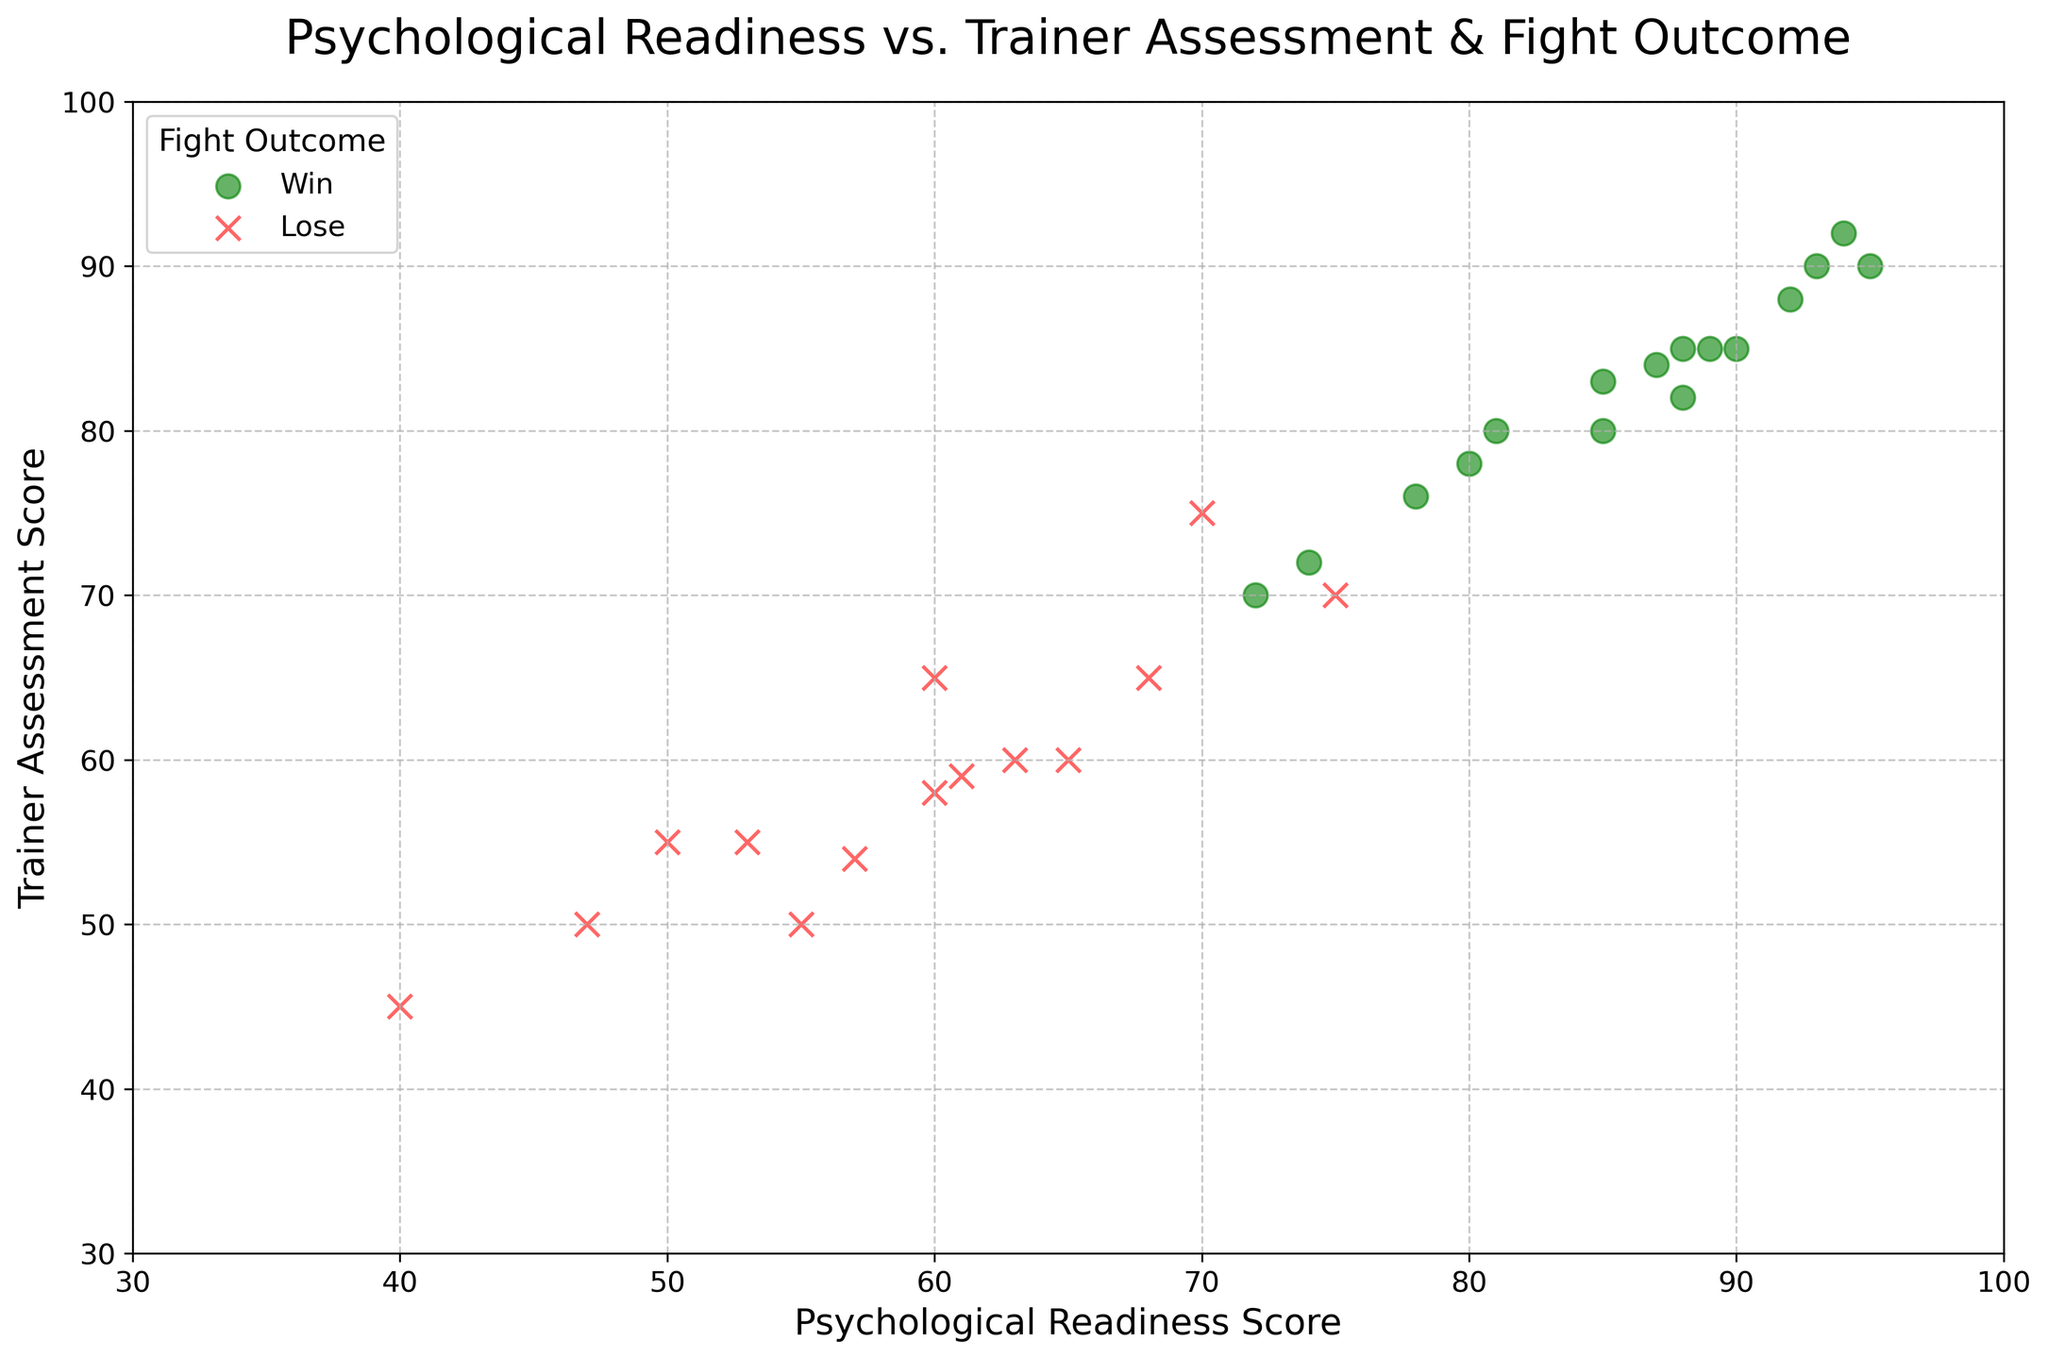What colors represent the winning and losing outcomes in the plot? The plot uses different colors to differentiate between winning and losing outcomes. By observing the legend, we can see that "Win" is represented by green, and "Lose" is represented by red.
Answer: Winning is green, Losing is red What is the common range of Psychological Readiness Scores for fighters who win? By observing the scatter plot, we see the green markers, which represent the winning fighters, are generally clustered between 80 and 95 on the Psychological Readiness Score axis.
Answer: 80 to 95 Which fighter has the highest Psychological Readiness Score? Did they win or lose their fight? The highest Psychological Readiness Score is 95, indicated by a green marker (win) in the scatter plot. The fighter with this score won their fight.
Answer: Fighter with 95 psychological readiness, Win Compare the Psychological Readiness Scores and Trainer Assessment Scores for winners and losers. Which group tends to have higher scores? By comparing the clusters of green (winners) and red (losers) markers, we observe that the green markers are generally in the higher range of both Psychological Readiness Scores and Trainer Assessment Scores, indicating that winners tend to have higher scores in both metrics.
Answer: Winners have higher scores What is the average Psychological Readiness Score of the losing fighters? The Psychological Readiness Scores of the losing fighters are 75, 60, 50, 70, 65, 55, 40, 47, 60, 53, 63, 57, and 61. Counting up these values and dividing by the number of values gives an average of (75 + 60 + 50 + 70 + 65 + 55 + 40 + 47 + 60 + 53 + 63 + 57 + 61) / 13 ≈ 58.54.
Answer: Approximately 58.54 Which Psychological Readiness Score has a corresponding Trainer Assessment Score of 60? Did that fighter win or lose? Referring to the scatter plot, we identify a red marker (lose) at the coordinates (65, 60) and another red marker at (63, 60). Both fighters with Psychological Readiness Scores of 65 and 63 have a Trainer Assessment Score of 60, and both lost their fights.
Answer: 65 and 63, both lost How many fighters scored below 60 on the Psychological Readiness Scale? How many of them won their fights? Observing the scatter plot, we count the markers below the Psychological Readiness Score of 60 and find three red markers (losers) at 50, 55, 40, 47, 53, and 57. None of these markers are green, hence none of these fighters won their fights.
Answer: 6 fighters, 0 wins Compare the largest Psychological Readiness Score difference between any two winning fighters. The range of Psychological Readiness Scores for winning fighters is from 72 to 95. The largest difference between any two winning fighters is 95 - 72 = 23.
Answer: 23 Is there a visible trend between Psychological Readiness Scores and Trainer Assessment Scores for winners? In the scatter plot, we can observe that the green markers (winners) appear to show a positive correlation, where higher Psychological Readiness Scores tend to be associated with higher Trainer Assessment Scores.
Answer: Positive correlation What is the highest Trainer Assessment Score, and what was the corresponding fight outcome? Observing the scatter plot, the highest Trainer Assessment Score is 92. The corresponding Psychological Readiness Score is 94 with a green marker, indicating the fighter won their fight.
Answer: Trainer Assessment Score 92, Win 